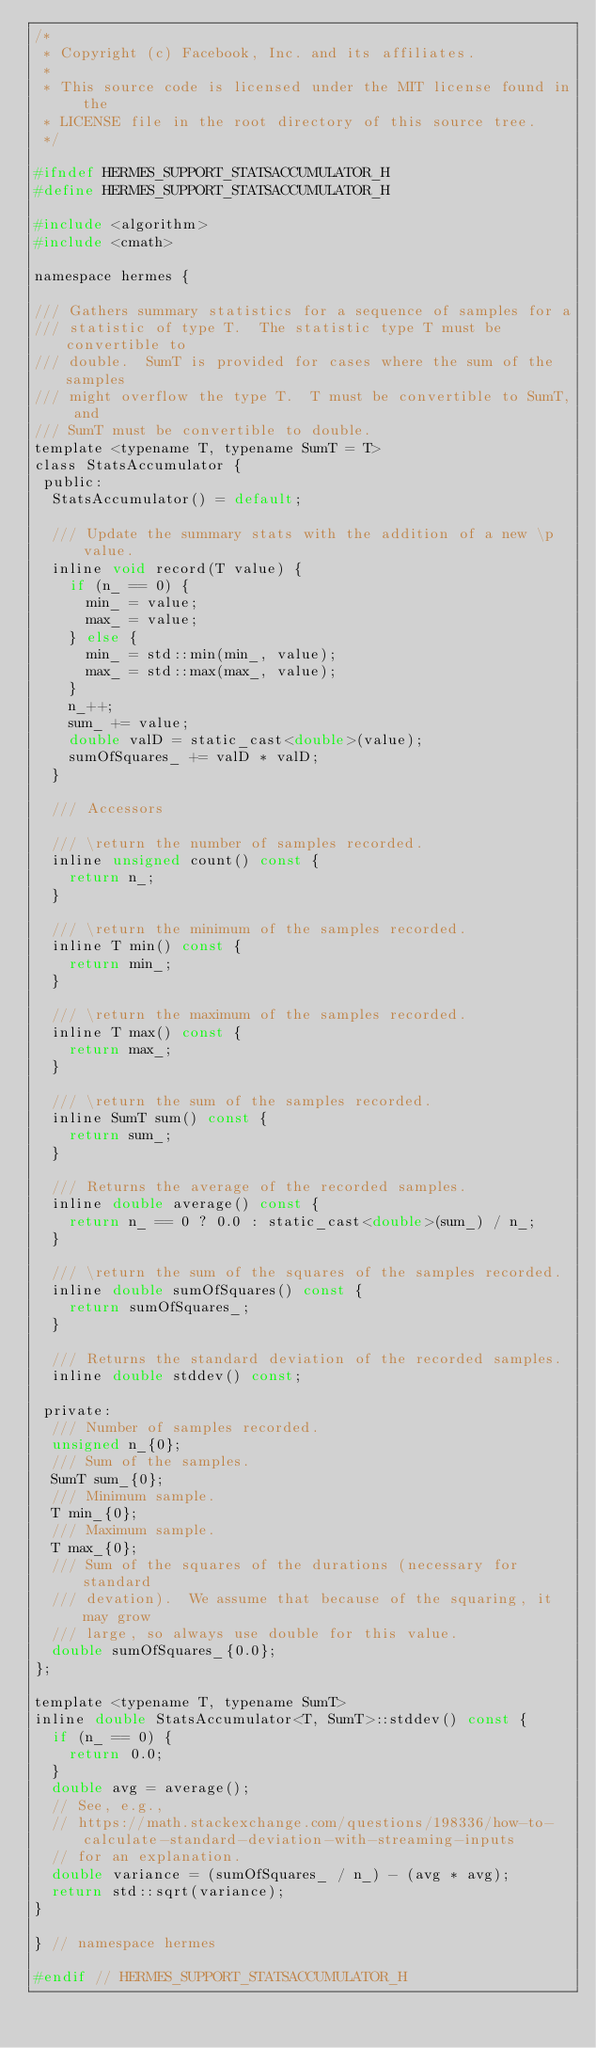Convert code to text. <code><loc_0><loc_0><loc_500><loc_500><_C_>/*
 * Copyright (c) Facebook, Inc. and its affiliates.
 *
 * This source code is licensed under the MIT license found in the
 * LICENSE file in the root directory of this source tree.
 */

#ifndef HERMES_SUPPORT_STATSACCUMULATOR_H
#define HERMES_SUPPORT_STATSACCUMULATOR_H

#include <algorithm>
#include <cmath>

namespace hermes {

/// Gathers summary statistics for a sequence of samples for a
/// statistic of type T.  The statistic type T must be convertible to
/// double.  SumT is provided for cases where the sum of the samples
/// might overflow the type T.  T must be convertible to SumT, and
/// SumT must be convertible to double.
template <typename T, typename SumT = T>
class StatsAccumulator {
 public:
  StatsAccumulator() = default;

  /// Update the summary stats with the addition of a new \p value.
  inline void record(T value) {
    if (n_ == 0) {
      min_ = value;
      max_ = value;
    } else {
      min_ = std::min(min_, value);
      max_ = std::max(max_, value);
    }
    n_++;
    sum_ += value;
    double valD = static_cast<double>(value);
    sumOfSquares_ += valD * valD;
  }

  /// Accessors

  /// \return the number of samples recorded.
  inline unsigned count() const {
    return n_;
  }

  /// \return the minimum of the samples recorded.
  inline T min() const {
    return min_;
  }

  /// \return the maximum of the samples recorded.
  inline T max() const {
    return max_;
  }

  /// \return the sum of the samples recorded.
  inline SumT sum() const {
    return sum_;
  }

  /// Returns the average of the recorded samples.
  inline double average() const {
    return n_ == 0 ? 0.0 : static_cast<double>(sum_) / n_;
  }

  /// \return the sum of the squares of the samples recorded.
  inline double sumOfSquares() const {
    return sumOfSquares_;
  }

  /// Returns the standard deviation of the recorded samples.
  inline double stddev() const;

 private:
  /// Number of samples recorded.
  unsigned n_{0};
  /// Sum of the samples.
  SumT sum_{0};
  /// Minimum sample.
  T min_{0};
  /// Maximum sample.
  T max_{0};
  /// Sum of the squares of the durations (necessary for standard
  /// devation).  We assume that because of the squaring, it may grow
  /// large, so always use double for this value.
  double sumOfSquares_{0.0};
};

template <typename T, typename SumT>
inline double StatsAccumulator<T, SumT>::stddev() const {
  if (n_ == 0) {
    return 0.0;
  }
  double avg = average();
  // See, e.g.,
  // https://math.stackexchange.com/questions/198336/how-to-calculate-standard-deviation-with-streaming-inputs
  // for an explanation.
  double variance = (sumOfSquares_ / n_) - (avg * avg);
  return std::sqrt(variance);
}

} // namespace hermes

#endif // HERMES_SUPPORT_STATSACCUMULATOR_H
</code> 